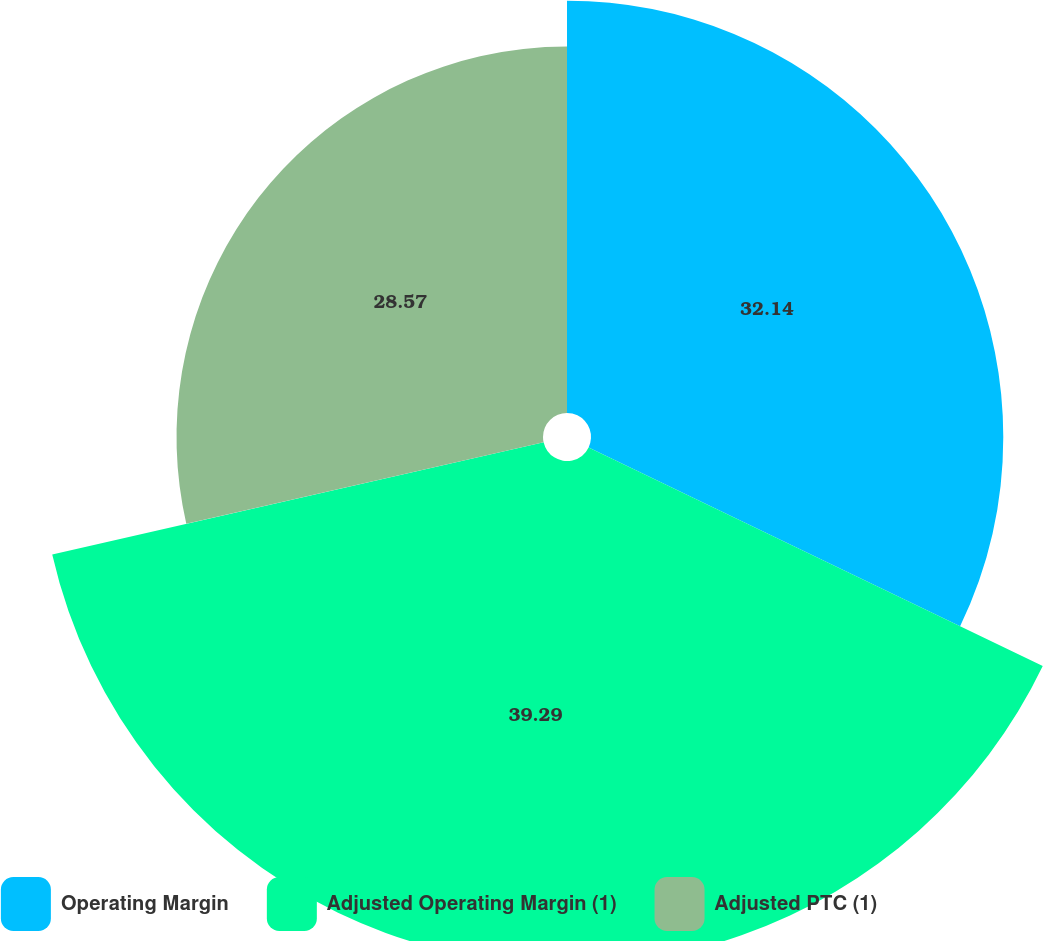<chart> <loc_0><loc_0><loc_500><loc_500><pie_chart><fcel>Operating Margin<fcel>Adjusted Operating Margin (1)<fcel>Adjusted PTC (1)<nl><fcel>32.14%<fcel>39.29%<fcel>28.57%<nl></chart> 